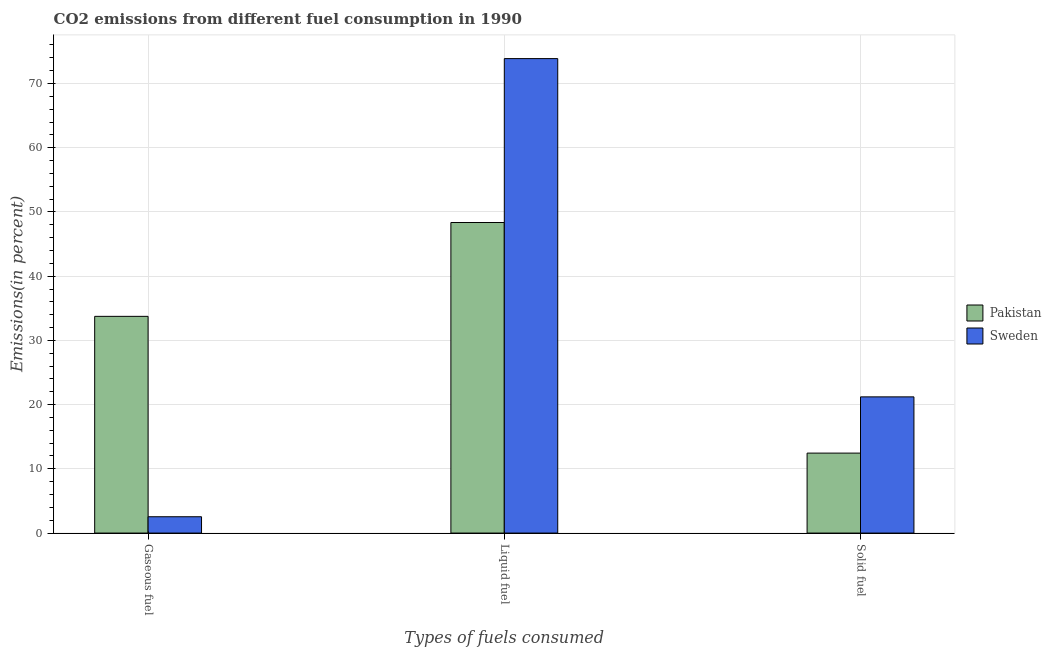Are the number of bars per tick equal to the number of legend labels?
Provide a succinct answer. Yes. How many bars are there on the 1st tick from the left?
Give a very brief answer. 2. How many bars are there on the 3rd tick from the right?
Your response must be concise. 2. What is the label of the 1st group of bars from the left?
Give a very brief answer. Gaseous fuel. What is the percentage of solid fuel emission in Pakistan?
Give a very brief answer. 12.45. Across all countries, what is the maximum percentage of liquid fuel emission?
Give a very brief answer. 73.87. Across all countries, what is the minimum percentage of gaseous fuel emission?
Provide a short and direct response. 2.54. In which country was the percentage of gaseous fuel emission minimum?
Offer a terse response. Sweden. What is the total percentage of liquid fuel emission in the graph?
Provide a succinct answer. 122.23. What is the difference between the percentage of liquid fuel emission in Pakistan and that in Sweden?
Your response must be concise. -25.52. What is the difference between the percentage of liquid fuel emission in Sweden and the percentage of gaseous fuel emission in Pakistan?
Your answer should be compact. 40.13. What is the average percentage of liquid fuel emission per country?
Keep it short and to the point. 61.11. What is the difference between the percentage of solid fuel emission and percentage of gaseous fuel emission in Pakistan?
Make the answer very short. -21.29. In how many countries, is the percentage of gaseous fuel emission greater than 58 %?
Provide a short and direct response. 0. What is the ratio of the percentage of solid fuel emission in Sweden to that in Pakistan?
Your answer should be compact. 1.7. What is the difference between the highest and the second highest percentage of gaseous fuel emission?
Offer a very short reply. 31.2. What is the difference between the highest and the lowest percentage of liquid fuel emission?
Provide a short and direct response. 25.52. Is the sum of the percentage of liquid fuel emission in Sweden and Pakistan greater than the maximum percentage of gaseous fuel emission across all countries?
Your answer should be compact. Yes. Are all the bars in the graph horizontal?
Ensure brevity in your answer.  No. What is the difference between two consecutive major ticks on the Y-axis?
Your answer should be compact. 10. Are the values on the major ticks of Y-axis written in scientific E-notation?
Provide a succinct answer. No. Does the graph contain any zero values?
Keep it short and to the point. No. Where does the legend appear in the graph?
Keep it short and to the point. Center right. How many legend labels are there?
Offer a terse response. 2. What is the title of the graph?
Offer a terse response. CO2 emissions from different fuel consumption in 1990. Does "Macao" appear as one of the legend labels in the graph?
Your answer should be very brief. No. What is the label or title of the X-axis?
Keep it short and to the point. Types of fuels consumed. What is the label or title of the Y-axis?
Offer a terse response. Emissions(in percent). What is the Emissions(in percent) of Pakistan in Gaseous fuel?
Make the answer very short. 33.74. What is the Emissions(in percent) of Sweden in Gaseous fuel?
Your response must be concise. 2.54. What is the Emissions(in percent) in Pakistan in Liquid fuel?
Make the answer very short. 48.35. What is the Emissions(in percent) of Sweden in Liquid fuel?
Provide a short and direct response. 73.87. What is the Emissions(in percent) of Pakistan in Solid fuel?
Your answer should be compact. 12.45. What is the Emissions(in percent) of Sweden in Solid fuel?
Offer a terse response. 21.21. Across all Types of fuels consumed, what is the maximum Emissions(in percent) of Pakistan?
Your response must be concise. 48.35. Across all Types of fuels consumed, what is the maximum Emissions(in percent) of Sweden?
Make the answer very short. 73.87. Across all Types of fuels consumed, what is the minimum Emissions(in percent) of Pakistan?
Ensure brevity in your answer.  12.45. Across all Types of fuels consumed, what is the minimum Emissions(in percent) in Sweden?
Give a very brief answer. 2.54. What is the total Emissions(in percent) in Pakistan in the graph?
Your answer should be very brief. 94.54. What is the total Emissions(in percent) in Sweden in the graph?
Your answer should be very brief. 97.62. What is the difference between the Emissions(in percent) in Pakistan in Gaseous fuel and that in Liquid fuel?
Keep it short and to the point. -14.61. What is the difference between the Emissions(in percent) in Sweden in Gaseous fuel and that in Liquid fuel?
Give a very brief answer. -71.33. What is the difference between the Emissions(in percent) in Pakistan in Gaseous fuel and that in Solid fuel?
Keep it short and to the point. 21.29. What is the difference between the Emissions(in percent) in Sweden in Gaseous fuel and that in Solid fuel?
Ensure brevity in your answer.  -18.66. What is the difference between the Emissions(in percent) of Pakistan in Liquid fuel and that in Solid fuel?
Provide a short and direct response. 35.9. What is the difference between the Emissions(in percent) of Sweden in Liquid fuel and that in Solid fuel?
Your answer should be compact. 52.67. What is the difference between the Emissions(in percent) of Pakistan in Gaseous fuel and the Emissions(in percent) of Sweden in Liquid fuel?
Ensure brevity in your answer.  -40.13. What is the difference between the Emissions(in percent) in Pakistan in Gaseous fuel and the Emissions(in percent) in Sweden in Solid fuel?
Your answer should be compact. 12.54. What is the difference between the Emissions(in percent) in Pakistan in Liquid fuel and the Emissions(in percent) in Sweden in Solid fuel?
Offer a very short reply. 27.15. What is the average Emissions(in percent) in Pakistan per Types of fuels consumed?
Keep it short and to the point. 31.52. What is the average Emissions(in percent) of Sweden per Types of fuels consumed?
Keep it short and to the point. 32.54. What is the difference between the Emissions(in percent) in Pakistan and Emissions(in percent) in Sweden in Gaseous fuel?
Give a very brief answer. 31.2. What is the difference between the Emissions(in percent) of Pakistan and Emissions(in percent) of Sweden in Liquid fuel?
Offer a very short reply. -25.52. What is the difference between the Emissions(in percent) in Pakistan and Emissions(in percent) in Sweden in Solid fuel?
Your answer should be very brief. -8.76. What is the ratio of the Emissions(in percent) in Pakistan in Gaseous fuel to that in Liquid fuel?
Your answer should be very brief. 0.7. What is the ratio of the Emissions(in percent) of Sweden in Gaseous fuel to that in Liquid fuel?
Ensure brevity in your answer.  0.03. What is the ratio of the Emissions(in percent) of Pakistan in Gaseous fuel to that in Solid fuel?
Provide a succinct answer. 2.71. What is the ratio of the Emissions(in percent) of Sweden in Gaseous fuel to that in Solid fuel?
Your answer should be compact. 0.12. What is the ratio of the Emissions(in percent) of Pakistan in Liquid fuel to that in Solid fuel?
Keep it short and to the point. 3.88. What is the ratio of the Emissions(in percent) in Sweden in Liquid fuel to that in Solid fuel?
Keep it short and to the point. 3.48. What is the difference between the highest and the second highest Emissions(in percent) in Pakistan?
Offer a terse response. 14.61. What is the difference between the highest and the second highest Emissions(in percent) of Sweden?
Your answer should be very brief. 52.67. What is the difference between the highest and the lowest Emissions(in percent) of Pakistan?
Offer a very short reply. 35.9. What is the difference between the highest and the lowest Emissions(in percent) of Sweden?
Your answer should be very brief. 71.33. 